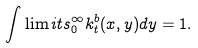<formula> <loc_0><loc_0><loc_500><loc_500>\int \lim i t s _ { 0 } ^ { \infty } k ^ { b } _ { t } ( x , y ) d y = 1 .</formula> 